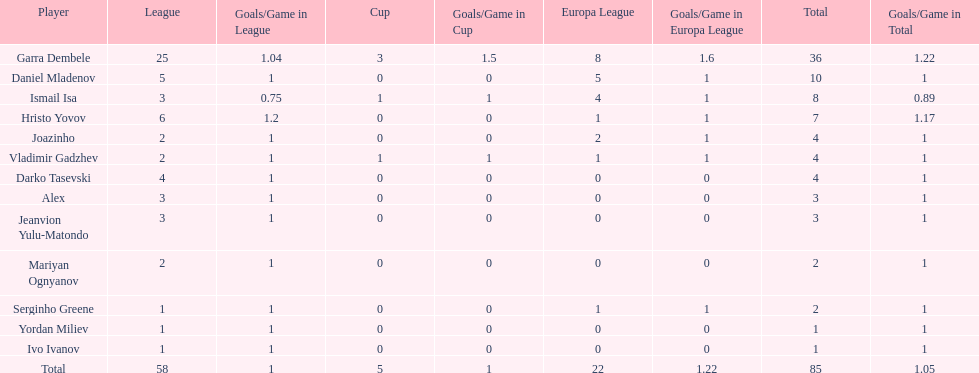Which players have at least 4 in the europa league? Garra Dembele, Daniel Mladenov, Ismail Isa. 